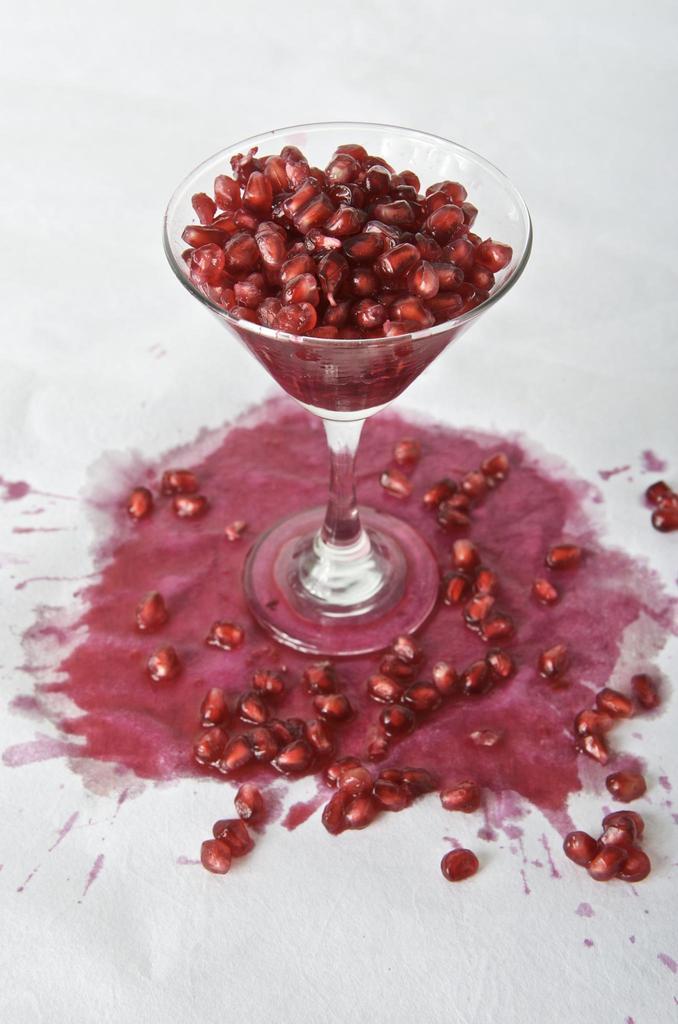How would you summarize this image in a sentence or two? In this image there is a glass in which there are pomegranate seeds. At the bottom there are some pomegranate seeds and juice of it. 